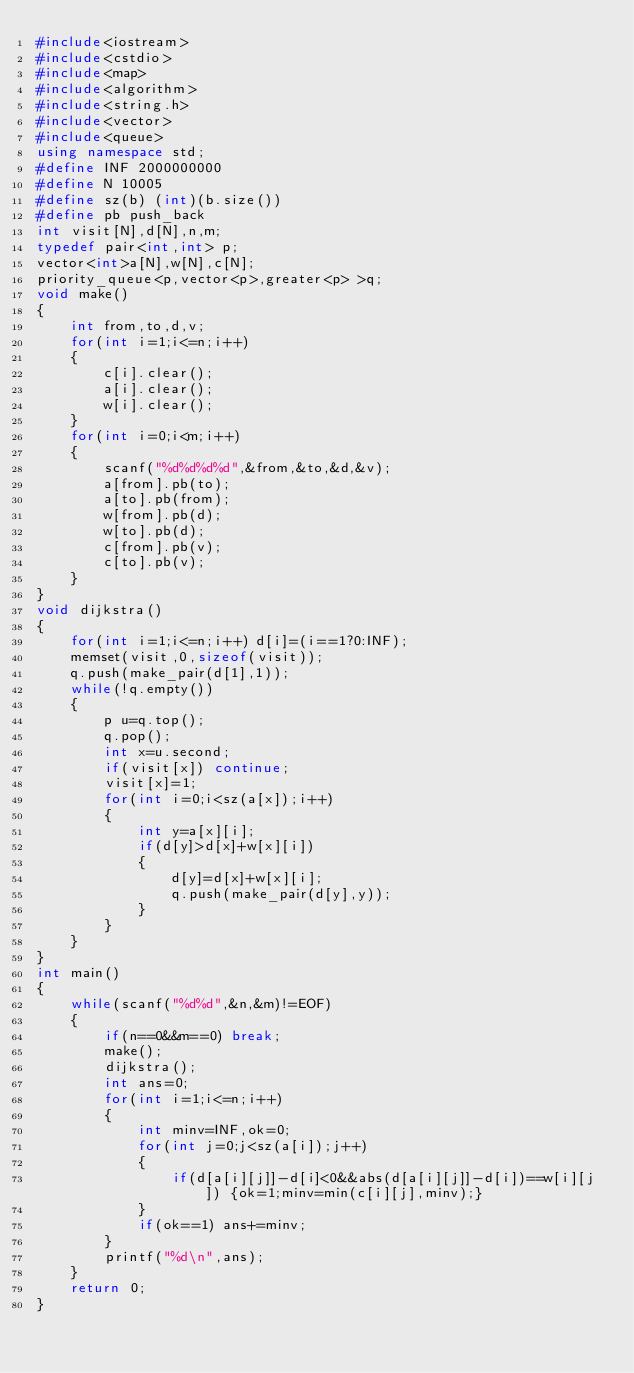Convert code to text. <code><loc_0><loc_0><loc_500><loc_500><_C++_>#include<iostream>
#include<cstdio>
#include<map>
#include<algorithm>
#include<string.h>
#include<vector>
#include<queue>
using namespace std;
#define INF 2000000000
#define N 10005
#define sz(b) (int)(b.size())
#define pb push_back
int visit[N],d[N],n,m;
typedef pair<int,int> p;
vector<int>a[N],w[N],c[N];
priority_queue<p,vector<p>,greater<p> >q;
void make()
{
    int from,to,d,v;
    for(int i=1;i<=n;i++)
    {
        c[i].clear();
        a[i].clear();
        w[i].clear();
    }
    for(int i=0;i<m;i++)
    {
        scanf("%d%d%d%d",&from,&to,&d,&v);
        a[from].pb(to);
        a[to].pb(from);
        w[from].pb(d);
        w[to].pb(d);
        c[from].pb(v);
        c[to].pb(v);
    }
}
void dijkstra()
{
    for(int i=1;i<=n;i++) d[i]=(i==1?0:INF);
    memset(visit,0,sizeof(visit));
    q.push(make_pair(d[1],1));
    while(!q.empty())
    {
        p u=q.top();
        q.pop();
        int x=u.second;
        if(visit[x]) continue;
        visit[x]=1;
        for(int i=0;i<sz(a[x]);i++)
        {
            int y=a[x][i];
            if(d[y]>d[x]+w[x][i])
            {
                d[y]=d[x]+w[x][i];
                q.push(make_pair(d[y],y));
            }
        }
    }
}
int main()
{
    while(scanf("%d%d",&n,&m)!=EOF)
    {
        if(n==0&&m==0) break;
        make();
        dijkstra();
        int ans=0;
        for(int i=1;i<=n;i++)
        {
            int minv=INF,ok=0;
            for(int j=0;j<sz(a[i]);j++)
            {
                if(d[a[i][j]]-d[i]<0&&abs(d[a[i][j]]-d[i])==w[i][j]) {ok=1;minv=min(c[i][j],minv);}
            }
            if(ok==1) ans+=minv;
        }
        printf("%d\n",ans);
    }
    return 0;
}</code> 